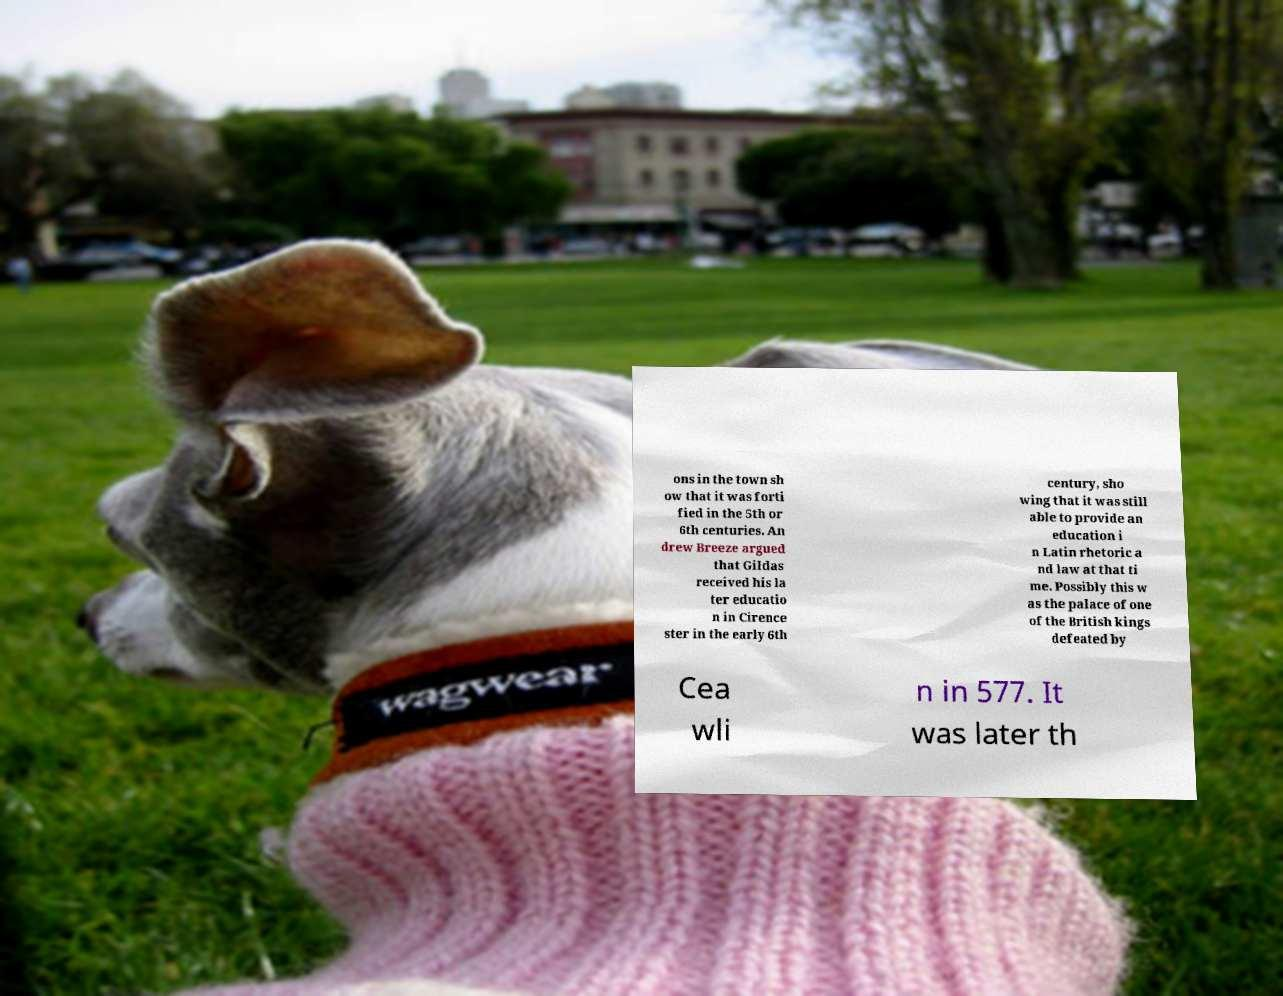Can you accurately transcribe the text from the provided image for me? ons in the town sh ow that it was forti fied in the 5th or 6th centuries. An drew Breeze argued that Gildas received his la ter educatio n in Cirence ster in the early 6th century, sho wing that it was still able to provide an education i n Latin rhetoric a nd law at that ti me. Possibly this w as the palace of one of the British kings defeated by Cea wli n in 577. It was later th 